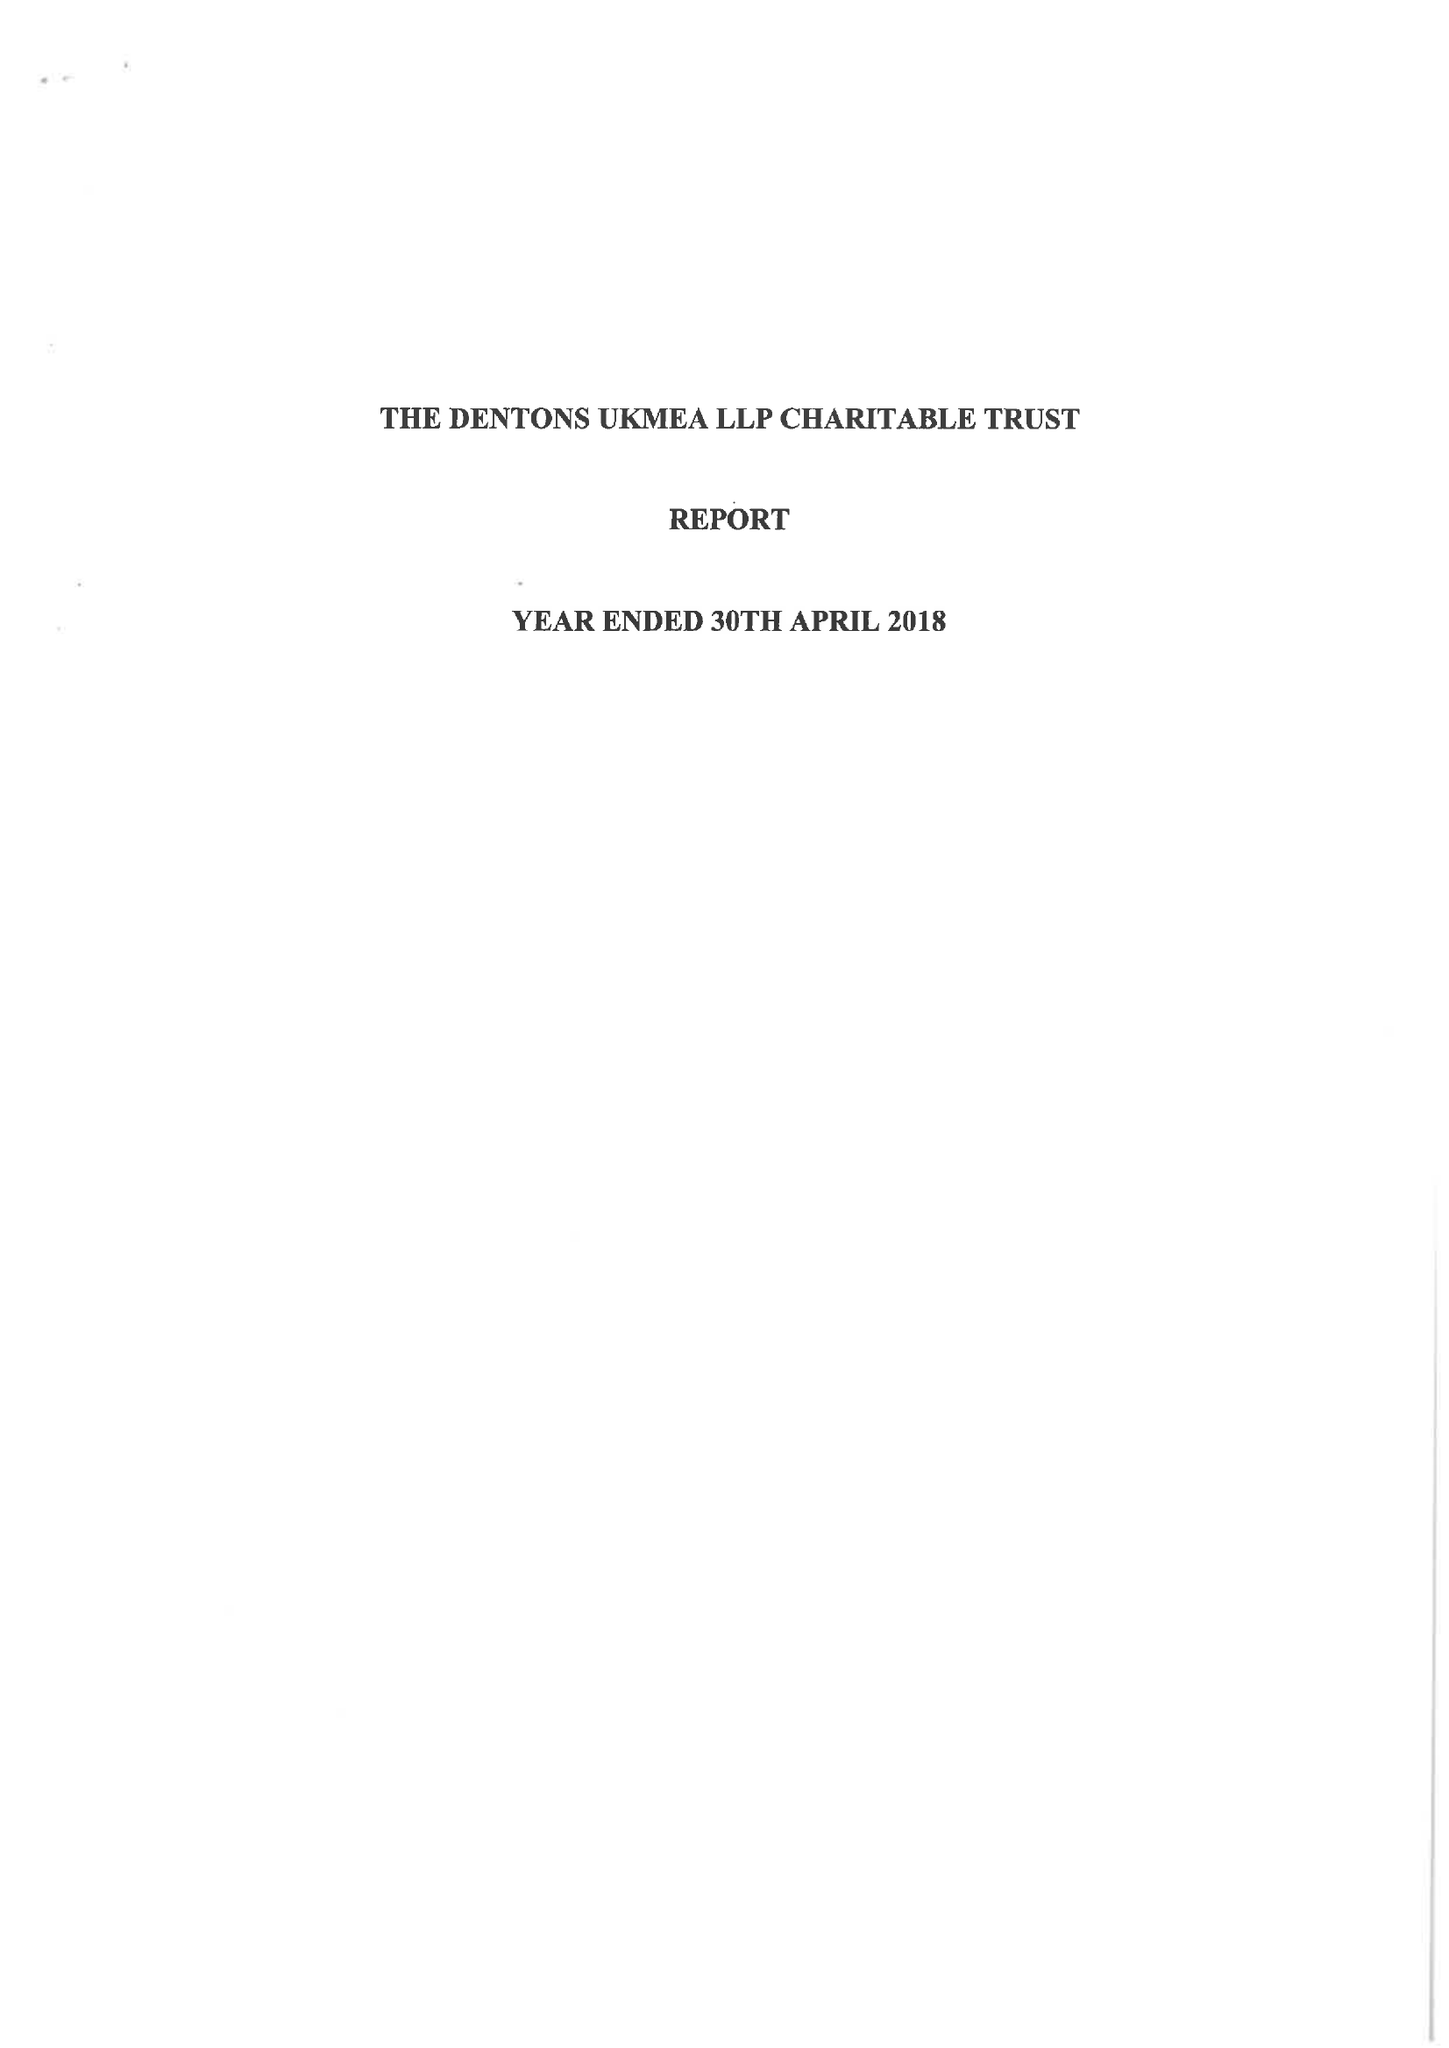What is the value for the address__post_town?
Answer the question using a single word or phrase. LONDON 